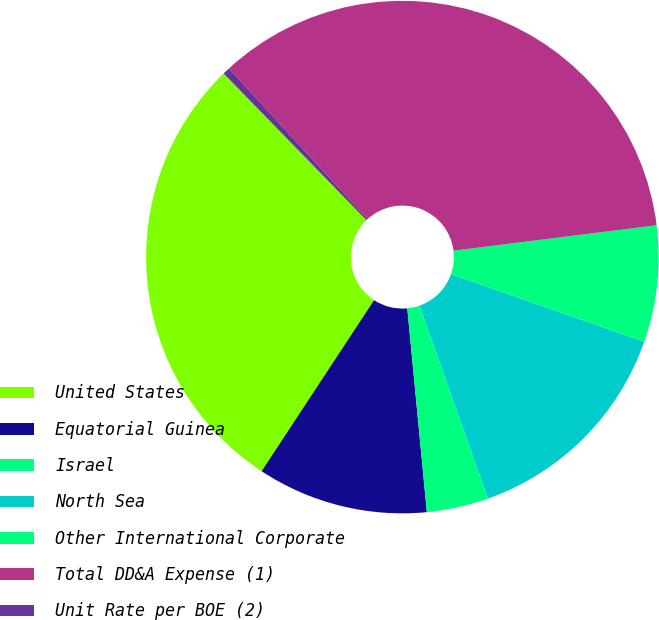Convert chart to OTSL. <chart><loc_0><loc_0><loc_500><loc_500><pie_chart><fcel>United States<fcel>Equatorial Guinea<fcel>Israel<fcel>North Sea<fcel>Other International Corporate<fcel>Total DD&A Expense (1)<fcel>Unit Rate per BOE (2)<nl><fcel>28.46%<fcel>10.78%<fcel>3.9%<fcel>14.22%<fcel>7.34%<fcel>34.85%<fcel>0.46%<nl></chart> 